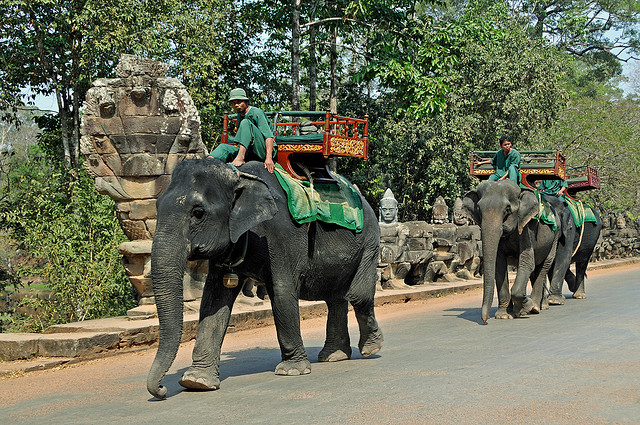Can you tell me more about the cultural significance of elephants in Thailand? Absolutely. In Thailand, elephants have been revered for centuries and hold great cultural and symbolic significance. They are considered a symbol of royal power, an icon of peaceful strength, and feature prominently in religious and historical narratives. Elephants have been used in warfare, royal ceremonies, and as a symbol of the king's divine right to rule. Festivals such as the Surin Elephant Round-up also celebrate these majestic animals with performances and parades. 